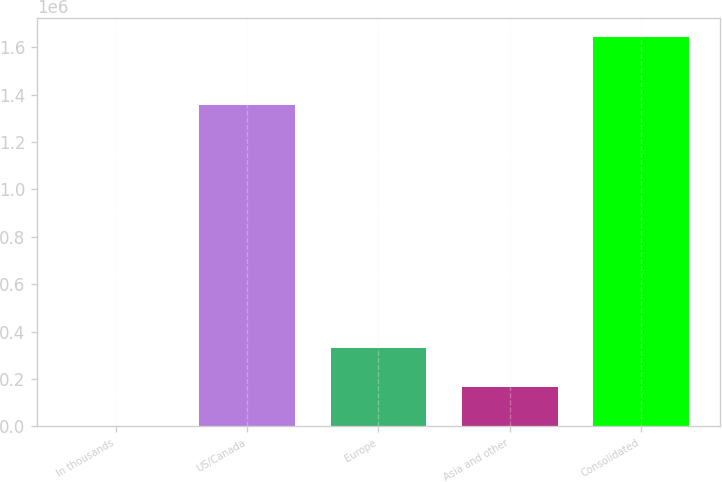<chart> <loc_0><loc_0><loc_500><loc_500><bar_chart><fcel>In thousands<fcel>US/Canada<fcel>Europe<fcel>Asia and other<fcel>Consolidated<nl><fcel>2003<fcel>1.35828e+06<fcel>330200<fcel>166101<fcel>1.64299e+06<nl></chart> 